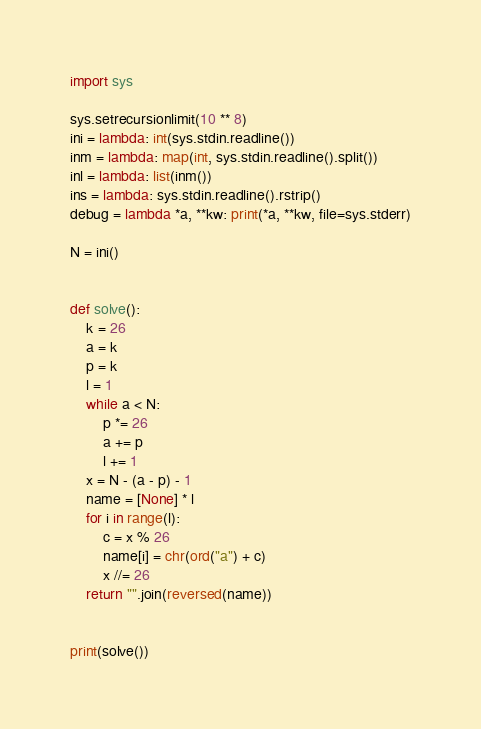<code> <loc_0><loc_0><loc_500><loc_500><_Python_>import sys

sys.setrecursionlimit(10 ** 8)
ini = lambda: int(sys.stdin.readline())
inm = lambda: map(int, sys.stdin.readline().split())
inl = lambda: list(inm())
ins = lambda: sys.stdin.readline().rstrip()
debug = lambda *a, **kw: print(*a, **kw, file=sys.stderr)

N = ini()


def solve():
    k = 26
    a = k
    p = k
    l = 1
    while a < N:
        p *= 26
        a += p
        l += 1
    x = N - (a - p) - 1
    name = [None] * l
    for i in range(l):
        c = x % 26
        name[i] = chr(ord("a") + c)
        x //= 26
    return "".join(reversed(name))


print(solve())
</code> 